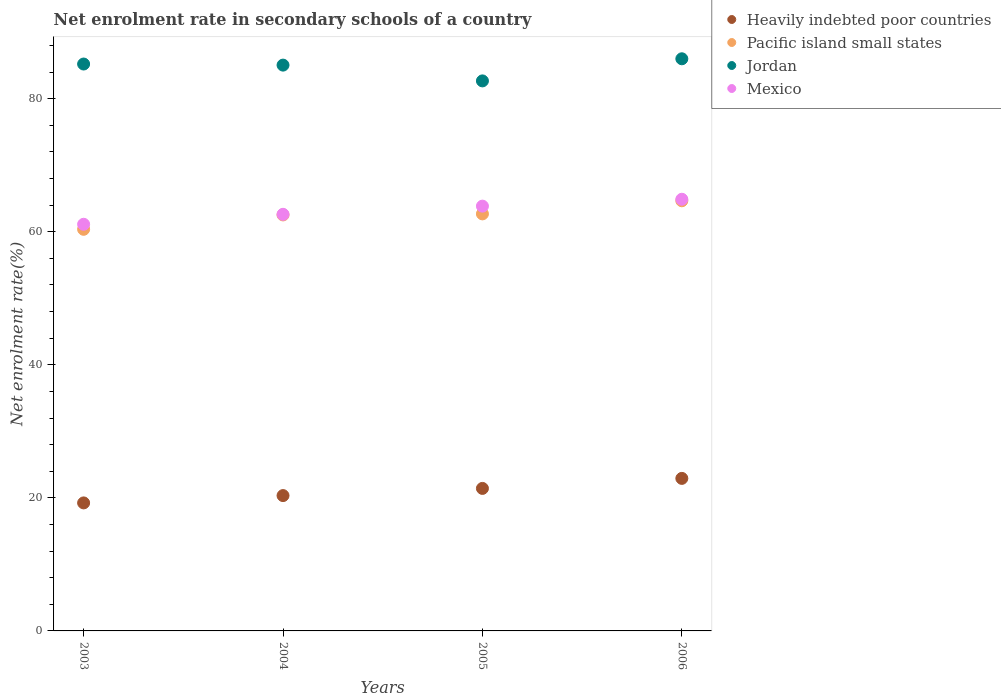Is the number of dotlines equal to the number of legend labels?
Provide a succinct answer. Yes. What is the net enrolment rate in secondary schools in Pacific island small states in 2004?
Give a very brief answer. 62.52. Across all years, what is the maximum net enrolment rate in secondary schools in Heavily indebted poor countries?
Your answer should be very brief. 22.92. Across all years, what is the minimum net enrolment rate in secondary schools in Jordan?
Give a very brief answer. 82.66. In which year was the net enrolment rate in secondary schools in Jordan maximum?
Offer a terse response. 2006. What is the total net enrolment rate in secondary schools in Heavily indebted poor countries in the graph?
Provide a short and direct response. 83.92. What is the difference between the net enrolment rate in secondary schools in Mexico in 2003 and that in 2005?
Your answer should be compact. -2.73. What is the difference between the net enrolment rate in secondary schools in Pacific island small states in 2006 and the net enrolment rate in secondary schools in Mexico in 2005?
Your answer should be compact. 0.8. What is the average net enrolment rate in secondary schools in Heavily indebted poor countries per year?
Provide a short and direct response. 20.98. In the year 2004, what is the difference between the net enrolment rate in secondary schools in Jordan and net enrolment rate in secondary schools in Heavily indebted poor countries?
Your response must be concise. 64.7. In how many years, is the net enrolment rate in secondary schools in Jordan greater than 56 %?
Provide a succinct answer. 4. What is the ratio of the net enrolment rate in secondary schools in Jordan in 2003 to that in 2006?
Give a very brief answer. 0.99. Is the net enrolment rate in secondary schools in Mexico in 2003 less than that in 2006?
Provide a succinct answer. Yes. What is the difference between the highest and the second highest net enrolment rate in secondary schools in Pacific island small states?
Offer a terse response. 1.97. What is the difference between the highest and the lowest net enrolment rate in secondary schools in Pacific island small states?
Ensure brevity in your answer.  4.29. In how many years, is the net enrolment rate in secondary schools in Pacific island small states greater than the average net enrolment rate in secondary schools in Pacific island small states taken over all years?
Your response must be concise. 2. Is the sum of the net enrolment rate in secondary schools in Jordan in 2003 and 2005 greater than the maximum net enrolment rate in secondary schools in Heavily indebted poor countries across all years?
Ensure brevity in your answer.  Yes. Is it the case that in every year, the sum of the net enrolment rate in secondary schools in Pacific island small states and net enrolment rate in secondary schools in Mexico  is greater than the sum of net enrolment rate in secondary schools in Jordan and net enrolment rate in secondary schools in Heavily indebted poor countries?
Give a very brief answer. Yes. Does the net enrolment rate in secondary schools in Heavily indebted poor countries monotonically increase over the years?
Ensure brevity in your answer.  Yes. Is the net enrolment rate in secondary schools in Mexico strictly greater than the net enrolment rate in secondary schools in Jordan over the years?
Your answer should be very brief. No. What is the difference between two consecutive major ticks on the Y-axis?
Make the answer very short. 20. Are the values on the major ticks of Y-axis written in scientific E-notation?
Your answer should be very brief. No. Does the graph contain grids?
Provide a succinct answer. No. Where does the legend appear in the graph?
Offer a very short reply. Top right. How many legend labels are there?
Offer a terse response. 4. How are the legend labels stacked?
Make the answer very short. Vertical. What is the title of the graph?
Provide a succinct answer. Net enrolment rate in secondary schools of a country. What is the label or title of the Y-axis?
Ensure brevity in your answer.  Net enrolment rate(%). What is the Net enrolment rate(%) of Heavily indebted poor countries in 2003?
Ensure brevity in your answer.  19.24. What is the Net enrolment rate(%) of Pacific island small states in 2003?
Make the answer very short. 60.36. What is the Net enrolment rate(%) in Jordan in 2003?
Your answer should be compact. 85.2. What is the Net enrolment rate(%) in Mexico in 2003?
Keep it short and to the point. 61.12. What is the Net enrolment rate(%) in Heavily indebted poor countries in 2004?
Ensure brevity in your answer.  20.34. What is the Net enrolment rate(%) in Pacific island small states in 2004?
Offer a terse response. 62.52. What is the Net enrolment rate(%) of Jordan in 2004?
Offer a very short reply. 85.04. What is the Net enrolment rate(%) in Mexico in 2004?
Your answer should be very brief. 62.61. What is the Net enrolment rate(%) of Heavily indebted poor countries in 2005?
Offer a terse response. 21.42. What is the Net enrolment rate(%) in Pacific island small states in 2005?
Your answer should be very brief. 62.68. What is the Net enrolment rate(%) of Jordan in 2005?
Keep it short and to the point. 82.66. What is the Net enrolment rate(%) in Mexico in 2005?
Your response must be concise. 63.84. What is the Net enrolment rate(%) of Heavily indebted poor countries in 2006?
Your response must be concise. 22.92. What is the Net enrolment rate(%) in Pacific island small states in 2006?
Provide a succinct answer. 64.65. What is the Net enrolment rate(%) in Jordan in 2006?
Make the answer very short. 85.99. What is the Net enrolment rate(%) of Mexico in 2006?
Make the answer very short. 64.88. Across all years, what is the maximum Net enrolment rate(%) in Heavily indebted poor countries?
Make the answer very short. 22.92. Across all years, what is the maximum Net enrolment rate(%) in Pacific island small states?
Your answer should be compact. 64.65. Across all years, what is the maximum Net enrolment rate(%) of Jordan?
Make the answer very short. 85.99. Across all years, what is the maximum Net enrolment rate(%) of Mexico?
Your response must be concise. 64.88. Across all years, what is the minimum Net enrolment rate(%) of Heavily indebted poor countries?
Provide a short and direct response. 19.24. Across all years, what is the minimum Net enrolment rate(%) in Pacific island small states?
Your response must be concise. 60.36. Across all years, what is the minimum Net enrolment rate(%) in Jordan?
Offer a very short reply. 82.66. Across all years, what is the minimum Net enrolment rate(%) of Mexico?
Your answer should be very brief. 61.12. What is the total Net enrolment rate(%) in Heavily indebted poor countries in the graph?
Make the answer very short. 83.92. What is the total Net enrolment rate(%) of Pacific island small states in the graph?
Provide a short and direct response. 250.2. What is the total Net enrolment rate(%) in Jordan in the graph?
Provide a succinct answer. 338.89. What is the total Net enrolment rate(%) in Mexico in the graph?
Your response must be concise. 252.45. What is the difference between the Net enrolment rate(%) of Heavily indebted poor countries in 2003 and that in 2004?
Keep it short and to the point. -1.1. What is the difference between the Net enrolment rate(%) of Pacific island small states in 2003 and that in 2004?
Make the answer very short. -2.16. What is the difference between the Net enrolment rate(%) in Jordan in 2003 and that in 2004?
Offer a very short reply. 0.16. What is the difference between the Net enrolment rate(%) in Mexico in 2003 and that in 2004?
Offer a terse response. -1.5. What is the difference between the Net enrolment rate(%) in Heavily indebted poor countries in 2003 and that in 2005?
Your answer should be compact. -2.18. What is the difference between the Net enrolment rate(%) of Pacific island small states in 2003 and that in 2005?
Your response must be concise. -2.32. What is the difference between the Net enrolment rate(%) in Jordan in 2003 and that in 2005?
Give a very brief answer. 2.53. What is the difference between the Net enrolment rate(%) in Mexico in 2003 and that in 2005?
Ensure brevity in your answer.  -2.73. What is the difference between the Net enrolment rate(%) of Heavily indebted poor countries in 2003 and that in 2006?
Your answer should be compact. -3.68. What is the difference between the Net enrolment rate(%) in Pacific island small states in 2003 and that in 2006?
Provide a short and direct response. -4.29. What is the difference between the Net enrolment rate(%) of Jordan in 2003 and that in 2006?
Make the answer very short. -0.79. What is the difference between the Net enrolment rate(%) of Mexico in 2003 and that in 2006?
Offer a terse response. -3.76. What is the difference between the Net enrolment rate(%) in Heavily indebted poor countries in 2004 and that in 2005?
Offer a terse response. -1.08. What is the difference between the Net enrolment rate(%) in Pacific island small states in 2004 and that in 2005?
Your answer should be very brief. -0.16. What is the difference between the Net enrolment rate(%) of Jordan in 2004 and that in 2005?
Your response must be concise. 2.37. What is the difference between the Net enrolment rate(%) of Mexico in 2004 and that in 2005?
Give a very brief answer. -1.23. What is the difference between the Net enrolment rate(%) in Heavily indebted poor countries in 2004 and that in 2006?
Offer a very short reply. -2.58. What is the difference between the Net enrolment rate(%) in Pacific island small states in 2004 and that in 2006?
Your response must be concise. -2.13. What is the difference between the Net enrolment rate(%) of Jordan in 2004 and that in 2006?
Offer a very short reply. -0.95. What is the difference between the Net enrolment rate(%) of Mexico in 2004 and that in 2006?
Provide a short and direct response. -2.26. What is the difference between the Net enrolment rate(%) in Heavily indebted poor countries in 2005 and that in 2006?
Offer a very short reply. -1.51. What is the difference between the Net enrolment rate(%) in Pacific island small states in 2005 and that in 2006?
Provide a short and direct response. -1.97. What is the difference between the Net enrolment rate(%) in Jordan in 2005 and that in 2006?
Offer a very short reply. -3.32. What is the difference between the Net enrolment rate(%) of Mexico in 2005 and that in 2006?
Give a very brief answer. -1.03. What is the difference between the Net enrolment rate(%) in Heavily indebted poor countries in 2003 and the Net enrolment rate(%) in Pacific island small states in 2004?
Provide a short and direct response. -43.28. What is the difference between the Net enrolment rate(%) in Heavily indebted poor countries in 2003 and the Net enrolment rate(%) in Jordan in 2004?
Your response must be concise. -65.8. What is the difference between the Net enrolment rate(%) of Heavily indebted poor countries in 2003 and the Net enrolment rate(%) of Mexico in 2004?
Offer a terse response. -43.37. What is the difference between the Net enrolment rate(%) of Pacific island small states in 2003 and the Net enrolment rate(%) of Jordan in 2004?
Offer a terse response. -24.68. What is the difference between the Net enrolment rate(%) in Pacific island small states in 2003 and the Net enrolment rate(%) in Mexico in 2004?
Keep it short and to the point. -2.25. What is the difference between the Net enrolment rate(%) of Jordan in 2003 and the Net enrolment rate(%) of Mexico in 2004?
Make the answer very short. 22.59. What is the difference between the Net enrolment rate(%) of Heavily indebted poor countries in 2003 and the Net enrolment rate(%) of Pacific island small states in 2005?
Your response must be concise. -43.44. What is the difference between the Net enrolment rate(%) of Heavily indebted poor countries in 2003 and the Net enrolment rate(%) of Jordan in 2005?
Your answer should be very brief. -63.42. What is the difference between the Net enrolment rate(%) in Heavily indebted poor countries in 2003 and the Net enrolment rate(%) in Mexico in 2005?
Your response must be concise. -44.6. What is the difference between the Net enrolment rate(%) of Pacific island small states in 2003 and the Net enrolment rate(%) of Jordan in 2005?
Offer a terse response. -22.31. What is the difference between the Net enrolment rate(%) in Pacific island small states in 2003 and the Net enrolment rate(%) in Mexico in 2005?
Make the answer very short. -3.48. What is the difference between the Net enrolment rate(%) in Jordan in 2003 and the Net enrolment rate(%) in Mexico in 2005?
Your answer should be very brief. 21.36. What is the difference between the Net enrolment rate(%) in Heavily indebted poor countries in 2003 and the Net enrolment rate(%) in Pacific island small states in 2006?
Provide a succinct answer. -45.41. What is the difference between the Net enrolment rate(%) of Heavily indebted poor countries in 2003 and the Net enrolment rate(%) of Jordan in 2006?
Offer a terse response. -66.75. What is the difference between the Net enrolment rate(%) in Heavily indebted poor countries in 2003 and the Net enrolment rate(%) in Mexico in 2006?
Your answer should be very brief. -45.64. What is the difference between the Net enrolment rate(%) of Pacific island small states in 2003 and the Net enrolment rate(%) of Jordan in 2006?
Provide a succinct answer. -25.63. What is the difference between the Net enrolment rate(%) of Pacific island small states in 2003 and the Net enrolment rate(%) of Mexico in 2006?
Your answer should be compact. -4.52. What is the difference between the Net enrolment rate(%) of Jordan in 2003 and the Net enrolment rate(%) of Mexico in 2006?
Offer a terse response. 20.32. What is the difference between the Net enrolment rate(%) of Heavily indebted poor countries in 2004 and the Net enrolment rate(%) of Pacific island small states in 2005?
Give a very brief answer. -42.34. What is the difference between the Net enrolment rate(%) of Heavily indebted poor countries in 2004 and the Net enrolment rate(%) of Jordan in 2005?
Provide a short and direct response. -62.32. What is the difference between the Net enrolment rate(%) in Heavily indebted poor countries in 2004 and the Net enrolment rate(%) in Mexico in 2005?
Your response must be concise. -43.5. What is the difference between the Net enrolment rate(%) of Pacific island small states in 2004 and the Net enrolment rate(%) of Jordan in 2005?
Ensure brevity in your answer.  -20.14. What is the difference between the Net enrolment rate(%) of Pacific island small states in 2004 and the Net enrolment rate(%) of Mexico in 2005?
Give a very brief answer. -1.32. What is the difference between the Net enrolment rate(%) of Jordan in 2004 and the Net enrolment rate(%) of Mexico in 2005?
Offer a terse response. 21.19. What is the difference between the Net enrolment rate(%) of Heavily indebted poor countries in 2004 and the Net enrolment rate(%) of Pacific island small states in 2006?
Keep it short and to the point. -44.31. What is the difference between the Net enrolment rate(%) of Heavily indebted poor countries in 2004 and the Net enrolment rate(%) of Jordan in 2006?
Offer a terse response. -65.65. What is the difference between the Net enrolment rate(%) in Heavily indebted poor countries in 2004 and the Net enrolment rate(%) in Mexico in 2006?
Your answer should be compact. -44.54. What is the difference between the Net enrolment rate(%) in Pacific island small states in 2004 and the Net enrolment rate(%) in Jordan in 2006?
Make the answer very short. -23.47. What is the difference between the Net enrolment rate(%) of Pacific island small states in 2004 and the Net enrolment rate(%) of Mexico in 2006?
Your answer should be very brief. -2.35. What is the difference between the Net enrolment rate(%) in Jordan in 2004 and the Net enrolment rate(%) in Mexico in 2006?
Offer a terse response. 20.16. What is the difference between the Net enrolment rate(%) of Heavily indebted poor countries in 2005 and the Net enrolment rate(%) of Pacific island small states in 2006?
Give a very brief answer. -43.23. What is the difference between the Net enrolment rate(%) in Heavily indebted poor countries in 2005 and the Net enrolment rate(%) in Jordan in 2006?
Ensure brevity in your answer.  -64.57. What is the difference between the Net enrolment rate(%) of Heavily indebted poor countries in 2005 and the Net enrolment rate(%) of Mexico in 2006?
Offer a very short reply. -43.46. What is the difference between the Net enrolment rate(%) in Pacific island small states in 2005 and the Net enrolment rate(%) in Jordan in 2006?
Provide a short and direct response. -23.31. What is the difference between the Net enrolment rate(%) in Pacific island small states in 2005 and the Net enrolment rate(%) in Mexico in 2006?
Ensure brevity in your answer.  -2.2. What is the difference between the Net enrolment rate(%) in Jordan in 2005 and the Net enrolment rate(%) in Mexico in 2006?
Provide a succinct answer. 17.79. What is the average Net enrolment rate(%) in Heavily indebted poor countries per year?
Your answer should be compact. 20.98. What is the average Net enrolment rate(%) of Pacific island small states per year?
Give a very brief answer. 62.55. What is the average Net enrolment rate(%) in Jordan per year?
Give a very brief answer. 84.72. What is the average Net enrolment rate(%) in Mexico per year?
Your answer should be very brief. 63.11. In the year 2003, what is the difference between the Net enrolment rate(%) of Heavily indebted poor countries and Net enrolment rate(%) of Pacific island small states?
Make the answer very short. -41.12. In the year 2003, what is the difference between the Net enrolment rate(%) in Heavily indebted poor countries and Net enrolment rate(%) in Jordan?
Give a very brief answer. -65.96. In the year 2003, what is the difference between the Net enrolment rate(%) in Heavily indebted poor countries and Net enrolment rate(%) in Mexico?
Your answer should be compact. -41.88. In the year 2003, what is the difference between the Net enrolment rate(%) in Pacific island small states and Net enrolment rate(%) in Jordan?
Offer a very short reply. -24.84. In the year 2003, what is the difference between the Net enrolment rate(%) of Pacific island small states and Net enrolment rate(%) of Mexico?
Offer a very short reply. -0.76. In the year 2003, what is the difference between the Net enrolment rate(%) of Jordan and Net enrolment rate(%) of Mexico?
Make the answer very short. 24.08. In the year 2004, what is the difference between the Net enrolment rate(%) in Heavily indebted poor countries and Net enrolment rate(%) in Pacific island small states?
Offer a terse response. -42.18. In the year 2004, what is the difference between the Net enrolment rate(%) in Heavily indebted poor countries and Net enrolment rate(%) in Jordan?
Offer a terse response. -64.7. In the year 2004, what is the difference between the Net enrolment rate(%) of Heavily indebted poor countries and Net enrolment rate(%) of Mexico?
Give a very brief answer. -42.27. In the year 2004, what is the difference between the Net enrolment rate(%) in Pacific island small states and Net enrolment rate(%) in Jordan?
Your answer should be compact. -22.52. In the year 2004, what is the difference between the Net enrolment rate(%) of Pacific island small states and Net enrolment rate(%) of Mexico?
Offer a terse response. -0.09. In the year 2004, what is the difference between the Net enrolment rate(%) in Jordan and Net enrolment rate(%) in Mexico?
Give a very brief answer. 22.42. In the year 2005, what is the difference between the Net enrolment rate(%) of Heavily indebted poor countries and Net enrolment rate(%) of Pacific island small states?
Make the answer very short. -41.26. In the year 2005, what is the difference between the Net enrolment rate(%) of Heavily indebted poor countries and Net enrolment rate(%) of Jordan?
Keep it short and to the point. -61.25. In the year 2005, what is the difference between the Net enrolment rate(%) of Heavily indebted poor countries and Net enrolment rate(%) of Mexico?
Offer a terse response. -42.42. In the year 2005, what is the difference between the Net enrolment rate(%) of Pacific island small states and Net enrolment rate(%) of Jordan?
Offer a very short reply. -19.99. In the year 2005, what is the difference between the Net enrolment rate(%) in Pacific island small states and Net enrolment rate(%) in Mexico?
Your response must be concise. -1.17. In the year 2005, what is the difference between the Net enrolment rate(%) of Jordan and Net enrolment rate(%) of Mexico?
Offer a terse response. 18.82. In the year 2006, what is the difference between the Net enrolment rate(%) in Heavily indebted poor countries and Net enrolment rate(%) in Pacific island small states?
Offer a terse response. -41.72. In the year 2006, what is the difference between the Net enrolment rate(%) in Heavily indebted poor countries and Net enrolment rate(%) in Jordan?
Your answer should be compact. -63.06. In the year 2006, what is the difference between the Net enrolment rate(%) of Heavily indebted poor countries and Net enrolment rate(%) of Mexico?
Provide a succinct answer. -41.95. In the year 2006, what is the difference between the Net enrolment rate(%) in Pacific island small states and Net enrolment rate(%) in Jordan?
Ensure brevity in your answer.  -21.34. In the year 2006, what is the difference between the Net enrolment rate(%) of Pacific island small states and Net enrolment rate(%) of Mexico?
Give a very brief answer. -0.23. In the year 2006, what is the difference between the Net enrolment rate(%) of Jordan and Net enrolment rate(%) of Mexico?
Your answer should be very brief. 21.11. What is the ratio of the Net enrolment rate(%) in Heavily indebted poor countries in 2003 to that in 2004?
Keep it short and to the point. 0.95. What is the ratio of the Net enrolment rate(%) of Pacific island small states in 2003 to that in 2004?
Offer a terse response. 0.97. What is the ratio of the Net enrolment rate(%) of Jordan in 2003 to that in 2004?
Offer a terse response. 1. What is the ratio of the Net enrolment rate(%) of Mexico in 2003 to that in 2004?
Make the answer very short. 0.98. What is the ratio of the Net enrolment rate(%) of Heavily indebted poor countries in 2003 to that in 2005?
Your response must be concise. 0.9. What is the ratio of the Net enrolment rate(%) in Pacific island small states in 2003 to that in 2005?
Your answer should be very brief. 0.96. What is the ratio of the Net enrolment rate(%) of Jordan in 2003 to that in 2005?
Make the answer very short. 1.03. What is the ratio of the Net enrolment rate(%) of Mexico in 2003 to that in 2005?
Provide a short and direct response. 0.96. What is the ratio of the Net enrolment rate(%) in Heavily indebted poor countries in 2003 to that in 2006?
Your answer should be compact. 0.84. What is the ratio of the Net enrolment rate(%) of Pacific island small states in 2003 to that in 2006?
Your answer should be compact. 0.93. What is the ratio of the Net enrolment rate(%) of Jordan in 2003 to that in 2006?
Offer a terse response. 0.99. What is the ratio of the Net enrolment rate(%) in Mexico in 2003 to that in 2006?
Ensure brevity in your answer.  0.94. What is the ratio of the Net enrolment rate(%) in Heavily indebted poor countries in 2004 to that in 2005?
Your answer should be very brief. 0.95. What is the ratio of the Net enrolment rate(%) of Jordan in 2004 to that in 2005?
Your response must be concise. 1.03. What is the ratio of the Net enrolment rate(%) of Mexico in 2004 to that in 2005?
Keep it short and to the point. 0.98. What is the ratio of the Net enrolment rate(%) in Heavily indebted poor countries in 2004 to that in 2006?
Keep it short and to the point. 0.89. What is the ratio of the Net enrolment rate(%) of Pacific island small states in 2004 to that in 2006?
Your response must be concise. 0.97. What is the ratio of the Net enrolment rate(%) of Jordan in 2004 to that in 2006?
Give a very brief answer. 0.99. What is the ratio of the Net enrolment rate(%) in Mexico in 2004 to that in 2006?
Keep it short and to the point. 0.97. What is the ratio of the Net enrolment rate(%) in Heavily indebted poor countries in 2005 to that in 2006?
Ensure brevity in your answer.  0.93. What is the ratio of the Net enrolment rate(%) of Pacific island small states in 2005 to that in 2006?
Offer a terse response. 0.97. What is the ratio of the Net enrolment rate(%) of Jordan in 2005 to that in 2006?
Ensure brevity in your answer.  0.96. What is the ratio of the Net enrolment rate(%) in Mexico in 2005 to that in 2006?
Give a very brief answer. 0.98. What is the difference between the highest and the second highest Net enrolment rate(%) of Heavily indebted poor countries?
Your response must be concise. 1.51. What is the difference between the highest and the second highest Net enrolment rate(%) in Pacific island small states?
Keep it short and to the point. 1.97. What is the difference between the highest and the second highest Net enrolment rate(%) in Jordan?
Give a very brief answer. 0.79. What is the difference between the highest and the lowest Net enrolment rate(%) of Heavily indebted poor countries?
Your answer should be compact. 3.68. What is the difference between the highest and the lowest Net enrolment rate(%) in Pacific island small states?
Your response must be concise. 4.29. What is the difference between the highest and the lowest Net enrolment rate(%) in Jordan?
Your answer should be compact. 3.32. What is the difference between the highest and the lowest Net enrolment rate(%) in Mexico?
Offer a terse response. 3.76. 